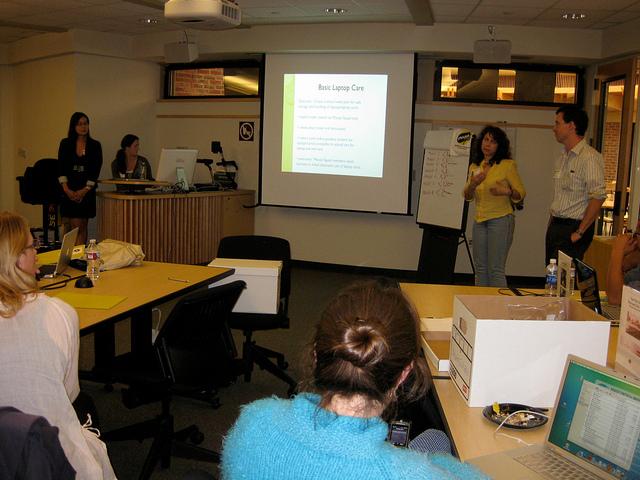What color of clothing is closest to the camera?
Give a very brief answer. Blue. What hairstyle does the girl in the blue shirt have?
Answer briefly. Bun. What has the man on the right done to his shirt sleeves?
Keep it brief. Rolled them up. 